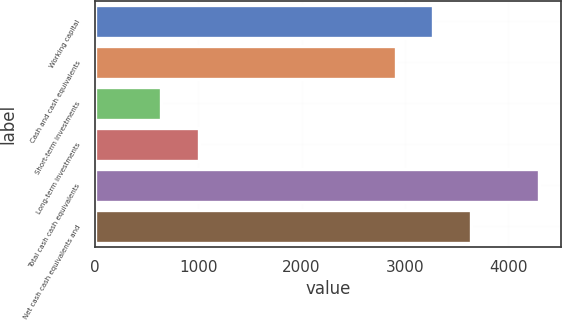<chart> <loc_0><loc_0><loc_500><loc_500><bar_chart><fcel>Working capital<fcel>Cash and cash equivalents<fcel>Short-term investments<fcel>Long-term investments<fcel>Total cash cash equivalents<fcel>Net cash cash equivalents and<nl><fcel>3275.51<fcel>2910.4<fcel>641.3<fcel>1006.41<fcel>4292.4<fcel>3640.62<nl></chart> 